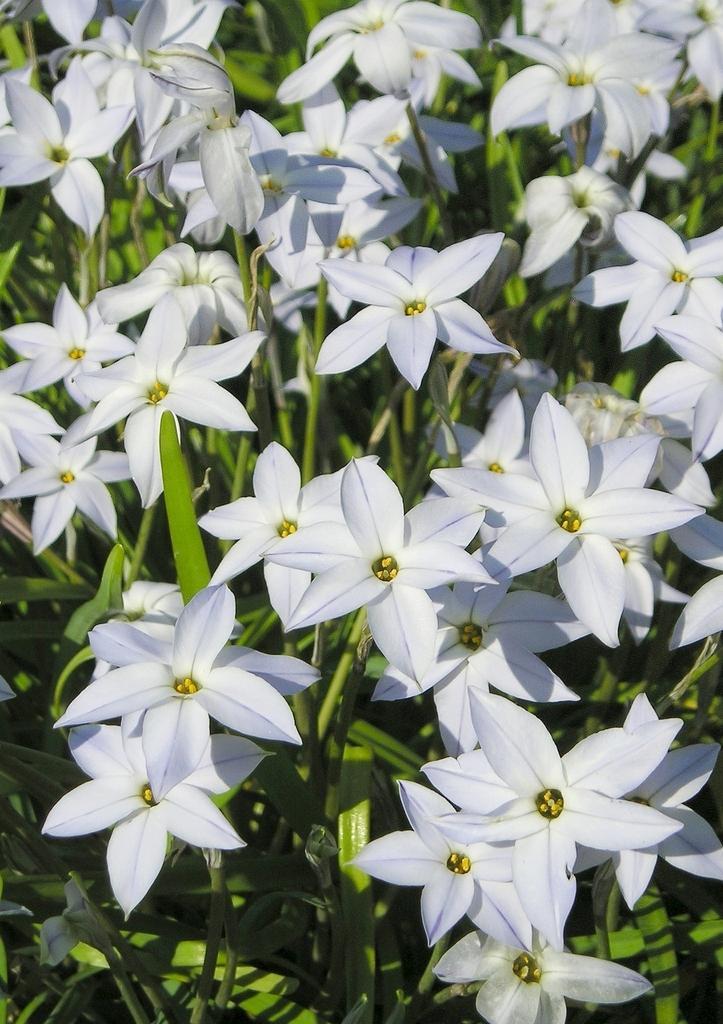Please provide a concise description of this image. In the image we can see some flowers and plants. 